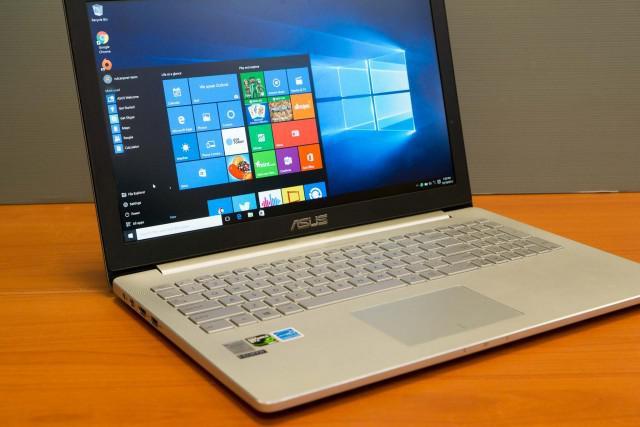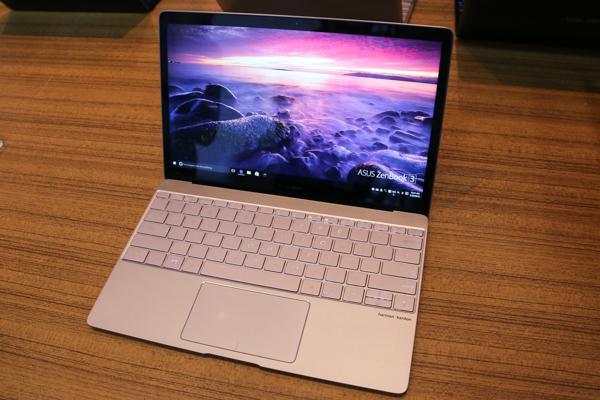The first image is the image on the left, the second image is the image on the right. Examine the images to the left and right. Is the description "Each image shows one open laptop, and the lefthand laptop has a cord plugged into its right side." accurate? Answer yes or no. No. The first image is the image on the left, the second image is the image on the right. Evaluate the accuracy of this statement regarding the images: "There are multiple squares shown on a laptop screen in one of the images.". Is it true? Answer yes or no. Yes. 